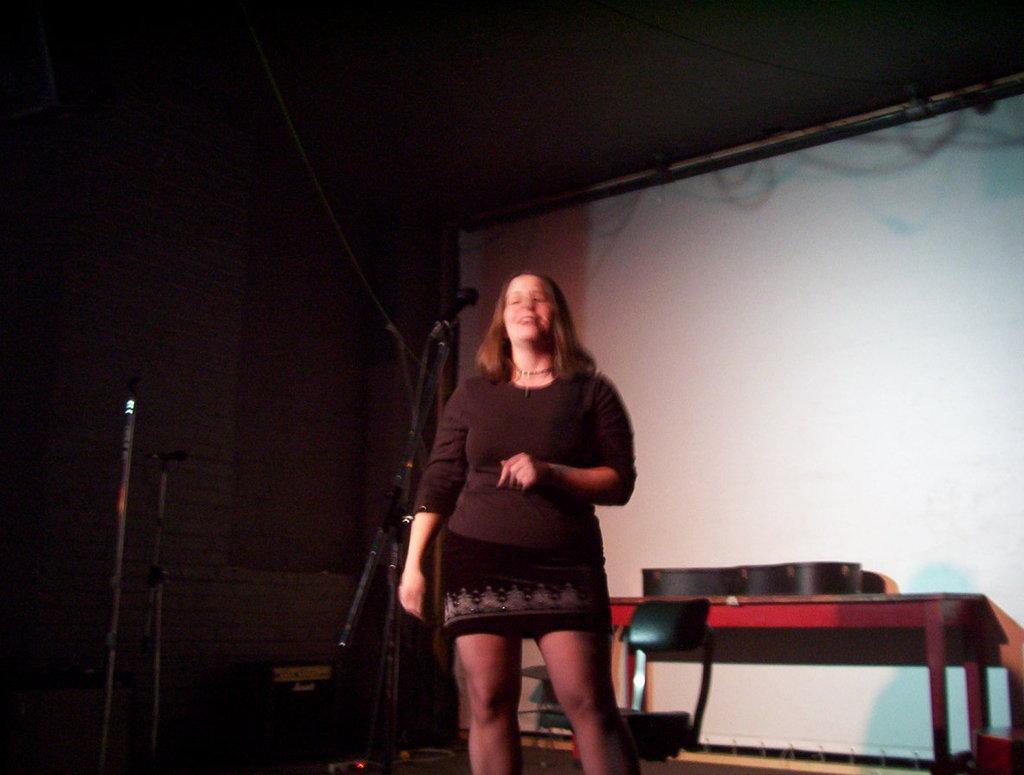Can you describe this image briefly? In this image I see a woman who is smiling and standing in front of a mic. In the background I see chair, table and the wall. 